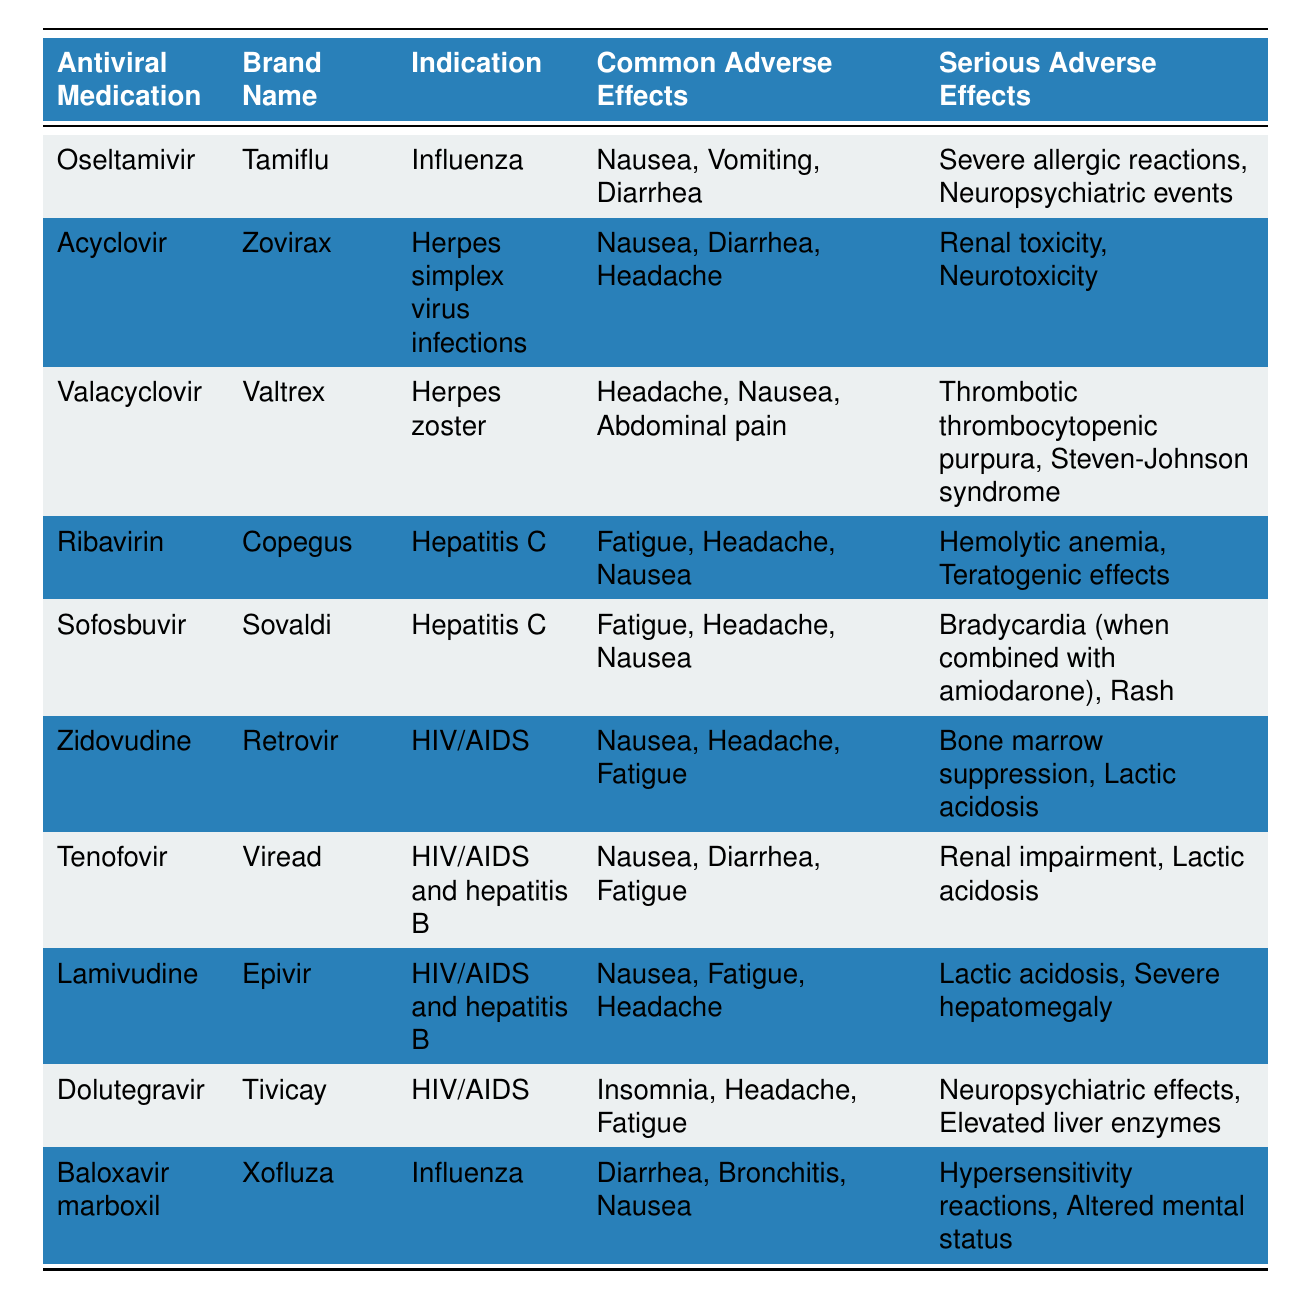What are the common adverse effects of Oseltamivir? The table lists "Nausea, Vomiting, Diarrhea" as the common adverse effects for Oseltamivir, which is under the relevant row for this medication.
Answer: Nausea, Vomiting, Diarrhea Does Acyclovir have any serious adverse effects? Yes, according to the table, Acyclovir has "Renal toxicity, Neurotoxicity" listed as its serious adverse effects.
Answer: Yes Which antiviral medication has "Fatigue" as a common adverse effect? By examining the table, "Fatigue" appears as a common adverse effect for Ribavirin, Sofosbuvir, Zidovudine, Tenofovir, and Lamivudine.
Answer: Ribavirin, Sofosbuvir, Zidovudine, Tenofovir, Lamivudine What is the serious adverse effect associated with Baloxavir marboxil? The table identifies "Hypersensitivity reactions, Altered mental status" as the serious adverse effects for Baloxavir marboxil.
Answer: Hypersensitivity reactions, Altered mental status Which antiviral medications are indicated for HIV/AIDS? The table shows Zidovudine, Tenofovir, Lamivudine, and Dolutegravir as antiviral medications indicated for HIV/AIDS. These can be found in the indication column.
Answer: Zidovudine, Tenofovir, Lamivudine, Dolutegravir What is the average number of common adverse effects across all listed antiviral medications? Counting the common adverse effects from each medication results in a total of 26 effects. Since there are 10 medications, the average is calculated as 26/10 = 2.6.
Answer: 2.6 Does Sofosbuvir have a serious adverse effect listed as renal impairment? No, the serious adverse effects listed for Sofosbuvir are "Bradycardia (when combined with amiodarone), Rash," not renal impairment.
Answer: No Which medication has "Neuropsychiatric events" as a serious adverse effect? According to the table, "Neuropsychiatric events" is a serious adverse effect listed for Oseltamivir.
Answer: Oseltamivir How many antiviral medications have "Nausea" as a common adverse effect? By reviewing the table, "Nausea" appears as a common adverse effect for Oseltamivir, Acyclovir, Valacyclovir, Ribavirin, Sofosbuvir, Zidovudine, Tenofovir, and Lamivudine, totaling 8 medications.
Answer: 8 